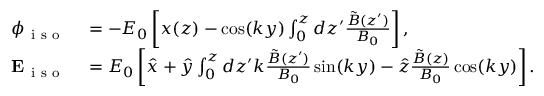<formula> <loc_0><loc_0><loc_500><loc_500>\begin{array} { r l } { \phi _ { i s o } } & = - E _ { 0 } \left [ x ( z ) - \cos ( k y ) \int _ { 0 } ^ { z } d z ^ { \prime } \frac { \tilde { B } ( z ^ { \prime } ) } { B _ { 0 } } \right ] , } \\ { E _ { i s o } } & = E _ { 0 } \left [ \hat { x } + \hat { y } \int _ { 0 } ^ { z } d z ^ { \prime } k \frac { \tilde { B } ( z ^ { \prime } ) } { B _ { 0 } } \sin ( k y ) - \hat { z } \frac { \tilde { B } ( z ) } { B _ { 0 } } \cos ( k y ) \right ] . } \end{array}</formula> 